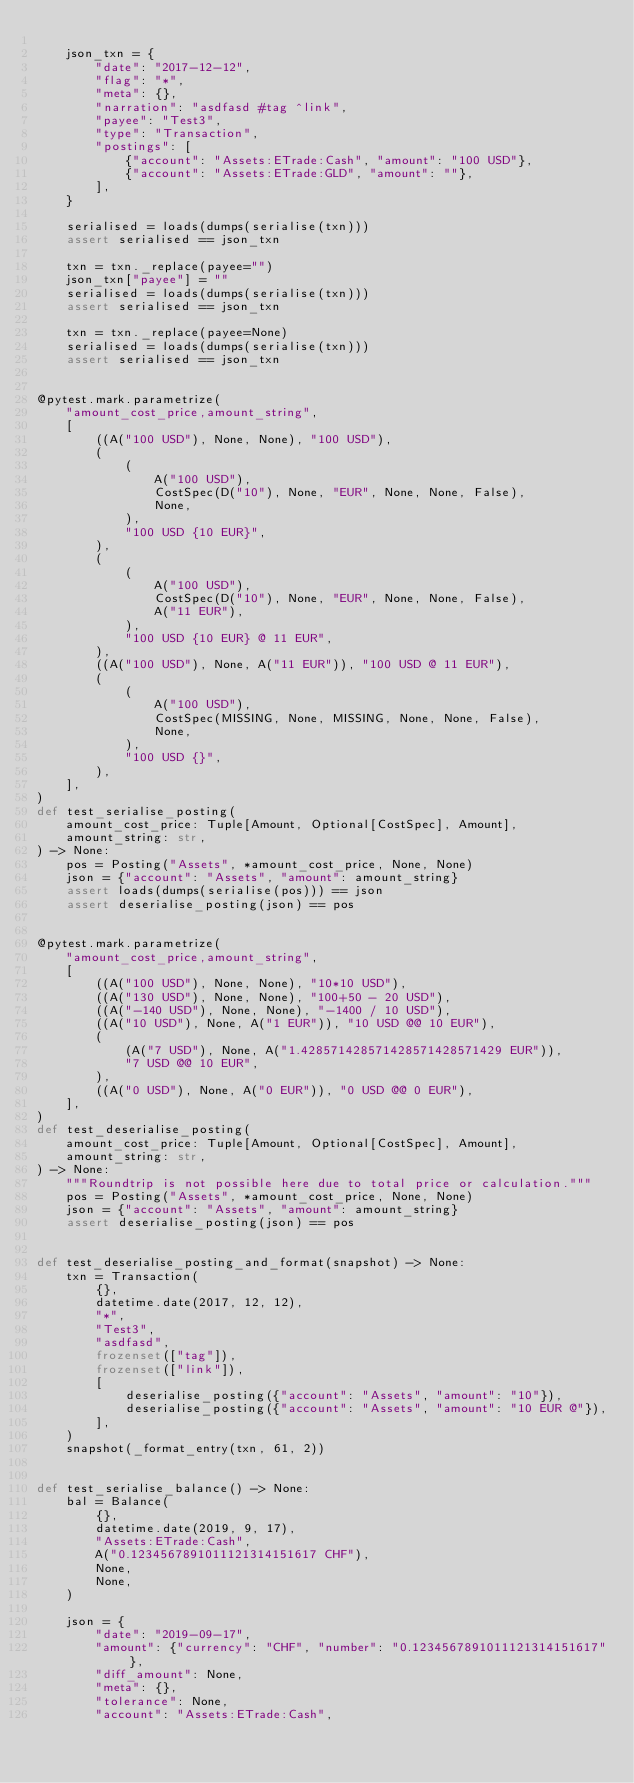<code> <loc_0><loc_0><loc_500><loc_500><_Python_>
    json_txn = {
        "date": "2017-12-12",
        "flag": "*",
        "meta": {},
        "narration": "asdfasd #tag ^link",
        "payee": "Test3",
        "type": "Transaction",
        "postings": [
            {"account": "Assets:ETrade:Cash", "amount": "100 USD"},
            {"account": "Assets:ETrade:GLD", "amount": ""},
        ],
    }

    serialised = loads(dumps(serialise(txn)))
    assert serialised == json_txn

    txn = txn._replace(payee="")
    json_txn["payee"] = ""
    serialised = loads(dumps(serialise(txn)))
    assert serialised == json_txn

    txn = txn._replace(payee=None)
    serialised = loads(dumps(serialise(txn)))
    assert serialised == json_txn


@pytest.mark.parametrize(
    "amount_cost_price,amount_string",
    [
        ((A("100 USD"), None, None), "100 USD"),
        (
            (
                A("100 USD"),
                CostSpec(D("10"), None, "EUR", None, None, False),
                None,
            ),
            "100 USD {10 EUR}",
        ),
        (
            (
                A("100 USD"),
                CostSpec(D("10"), None, "EUR", None, None, False),
                A("11 EUR"),
            ),
            "100 USD {10 EUR} @ 11 EUR",
        ),
        ((A("100 USD"), None, A("11 EUR")), "100 USD @ 11 EUR"),
        (
            (
                A("100 USD"),
                CostSpec(MISSING, None, MISSING, None, None, False),
                None,
            ),
            "100 USD {}",
        ),
    ],
)
def test_serialise_posting(
    amount_cost_price: Tuple[Amount, Optional[CostSpec], Amount],
    amount_string: str,
) -> None:
    pos = Posting("Assets", *amount_cost_price, None, None)
    json = {"account": "Assets", "amount": amount_string}
    assert loads(dumps(serialise(pos))) == json
    assert deserialise_posting(json) == pos


@pytest.mark.parametrize(
    "amount_cost_price,amount_string",
    [
        ((A("100 USD"), None, None), "10*10 USD"),
        ((A("130 USD"), None, None), "100+50 - 20 USD"),
        ((A("-140 USD"), None, None), "-1400 / 10 USD"),
        ((A("10 USD"), None, A("1 EUR")), "10 USD @@ 10 EUR"),
        (
            (A("7 USD"), None, A("1.428571428571428571428571429 EUR")),
            "7 USD @@ 10 EUR",
        ),
        ((A("0 USD"), None, A("0 EUR")), "0 USD @@ 0 EUR"),
    ],
)
def test_deserialise_posting(
    amount_cost_price: Tuple[Amount, Optional[CostSpec], Amount],
    amount_string: str,
) -> None:
    """Roundtrip is not possible here due to total price or calculation."""
    pos = Posting("Assets", *amount_cost_price, None, None)
    json = {"account": "Assets", "amount": amount_string}
    assert deserialise_posting(json) == pos


def test_deserialise_posting_and_format(snapshot) -> None:
    txn = Transaction(
        {},
        datetime.date(2017, 12, 12),
        "*",
        "Test3",
        "asdfasd",
        frozenset(["tag"]),
        frozenset(["link"]),
        [
            deserialise_posting({"account": "Assets", "amount": "10"}),
            deserialise_posting({"account": "Assets", "amount": "10 EUR @"}),
        ],
    )
    snapshot(_format_entry(txn, 61, 2))


def test_serialise_balance() -> None:
    bal = Balance(
        {},
        datetime.date(2019, 9, 17),
        "Assets:ETrade:Cash",
        A("0.1234567891011121314151617 CHF"),
        None,
        None,
    )

    json = {
        "date": "2019-09-17",
        "amount": {"currency": "CHF", "number": "0.1234567891011121314151617"},
        "diff_amount": None,
        "meta": {},
        "tolerance": None,
        "account": "Assets:ETrade:Cash",</code> 